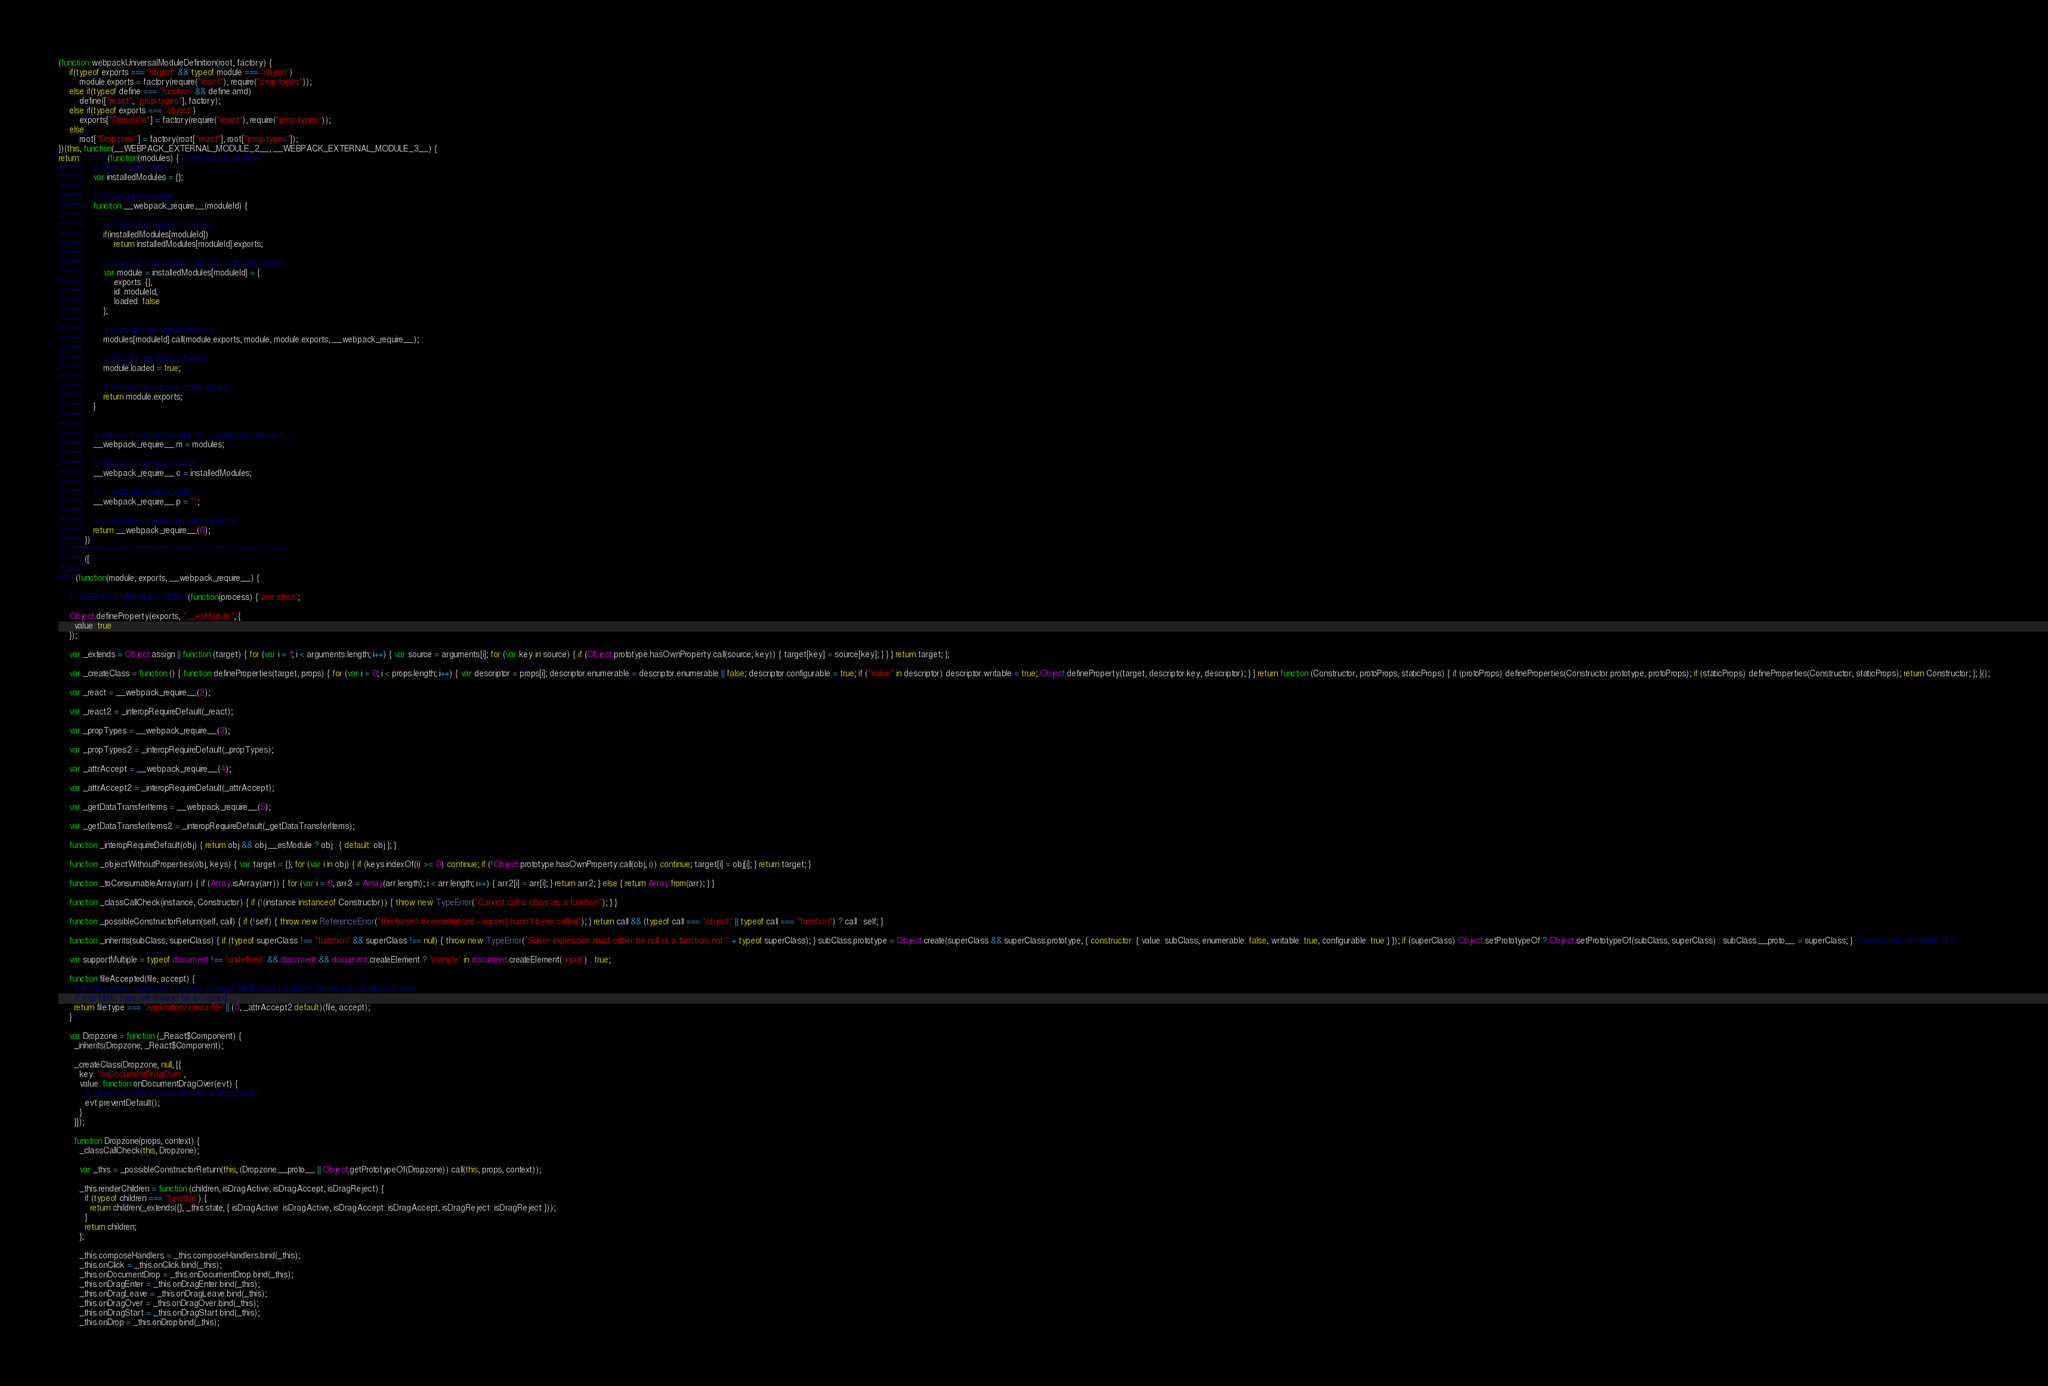Convert code to text. <code><loc_0><loc_0><loc_500><loc_500><_JavaScript_>(function webpackUniversalModuleDefinition(root, factory) {
	if(typeof exports === 'object' && typeof module === 'object')
		module.exports = factory(require("react"), require("prop-types"));
	else if(typeof define === 'function' && define.amd)
		define(["react", "prop-types"], factory);
	else if(typeof exports === 'object')
		exports["Dropzone"] = factory(require("react"), require("prop-types"));
	else
		root["Dropzone"] = factory(root["react"], root["prop-types"]);
})(this, function(__WEBPACK_EXTERNAL_MODULE_2__, __WEBPACK_EXTERNAL_MODULE_3__) {
return /******/ (function(modules) { // webpackBootstrap
/******/ 	// The module cache
/******/ 	var installedModules = {};
/******/
/******/ 	// The require function
/******/ 	function __webpack_require__(moduleId) {
/******/
/******/ 		// Check if module is in cache
/******/ 		if(installedModules[moduleId])
/******/ 			return installedModules[moduleId].exports;
/******/
/******/ 		// Create a new module (and put it into the cache)
/******/ 		var module = installedModules[moduleId] = {
/******/ 			exports: {},
/******/ 			id: moduleId,
/******/ 			loaded: false
/******/ 		};
/******/
/******/ 		// Execute the module function
/******/ 		modules[moduleId].call(module.exports, module, module.exports, __webpack_require__);
/******/
/******/ 		// Flag the module as loaded
/******/ 		module.loaded = true;
/******/
/******/ 		// Return the exports of the module
/******/ 		return module.exports;
/******/ 	}
/******/
/******/
/******/ 	// expose the modules object (__webpack_modules__)
/******/ 	__webpack_require__.m = modules;
/******/
/******/ 	// expose the module cache
/******/ 	__webpack_require__.c = installedModules;
/******/
/******/ 	// __webpack_public_path__
/******/ 	__webpack_require__.p = "";
/******/
/******/ 	// Load entry module and return exports
/******/ 	return __webpack_require__(0);
/******/ })
/************************************************************************/
/******/ ([
/* 0 */
/***/ (function(module, exports, __webpack_require__) {

	/* WEBPACK VAR INJECTION */(function(process) {'use strict';
	
	Object.defineProperty(exports, "__esModule", {
	  value: true
	});
	
	var _extends = Object.assign || function (target) { for (var i = 1; i < arguments.length; i++) { var source = arguments[i]; for (var key in source) { if (Object.prototype.hasOwnProperty.call(source, key)) { target[key] = source[key]; } } } return target; };
	
	var _createClass = function () { function defineProperties(target, props) { for (var i = 0; i < props.length; i++) { var descriptor = props[i]; descriptor.enumerable = descriptor.enumerable || false; descriptor.configurable = true; if ("value" in descriptor) descriptor.writable = true; Object.defineProperty(target, descriptor.key, descriptor); } } return function (Constructor, protoProps, staticProps) { if (protoProps) defineProperties(Constructor.prototype, protoProps); if (staticProps) defineProperties(Constructor, staticProps); return Constructor; }; }();
	
	var _react = __webpack_require__(2);
	
	var _react2 = _interopRequireDefault(_react);
	
	var _propTypes = __webpack_require__(3);
	
	var _propTypes2 = _interopRequireDefault(_propTypes);
	
	var _attrAccept = __webpack_require__(4);
	
	var _attrAccept2 = _interopRequireDefault(_attrAccept);
	
	var _getDataTransferItems = __webpack_require__(5);
	
	var _getDataTransferItems2 = _interopRequireDefault(_getDataTransferItems);
	
	function _interopRequireDefault(obj) { return obj && obj.__esModule ? obj : { default: obj }; }
	
	function _objectWithoutProperties(obj, keys) { var target = {}; for (var i in obj) { if (keys.indexOf(i) >= 0) continue; if (!Object.prototype.hasOwnProperty.call(obj, i)) continue; target[i] = obj[i]; } return target; }
	
	function _toConsumableArray(arr) { if (Array.isArray(arr)) { for (var i = 0, arr2 = Array(arr.length); i < arr.length; i++) { arr2[i] = arr[i]; } return arr2; } else { return Array.from(arr); } }
	
	function _classCallCheck(instance, Constructor) { if (!(instance instanceof Constructor)) { throw new TypeError("Cannot call a class as a function"); } }
	
	function _possibleConstructorReturn(self, call) { if (!self) { throw new ReferenceError("this hasn't been initialised - super() hasn't been called"); } return call && (typeof call === "object" || typeof call === "function") ? call : self; }
	
	function _inherits(subClass, superClass) { if (typeof superClass !== "function" && superClass !== null) { throw new TypeError("Super expression must either be null or a function, not " + typeof superClass); } subClass.prototype = Object.create(superClass && superClass.prototype, { constructor: { value: subClass, enumerable: false, writable: true, configurable: true } }); if (superClass) Object.setPrototypeOf ? Object.setPrototypeOf(subClass, superClass) : subClass.__proto__ = superClass; } /* eslint prefer-template: 0 */
	
	var supportMultiple = typeof document !== 'undefined' && document && document.createElement ? 'multiple' in document.createElement('input') : true;
	
	function fileAccepted(file, accept) {
	  // Firefox versions prior to 53 return a bogus MIME type for every file drag, so dragovers with
	  // that MIME type will always be accepted
	  return file.type === 'application/x-moz-file' || (0, _attrAccept2.default)(file, accept);
	}
	
	var Dropzone = function (_React$Component) {
	  _inherits(Dropzone, _React$Component);
	
	  _createClass(Dropzone, null, [{
	    key: 'onDocumentDragOver',
	    value: function onDocumentDragOver(evt) {
	      // allow the entire document to be a drag target
	      evt.preventDefault();
	    }
	  }]);
	
	  function Dropzone(props, context) {
	    _classCallCheck(this, Dropzone);
	
	    var _this = _possibleConstructorReturn(this, (Dropzone.__proto__ || Object.getPrototypeOf(Dropzone)).call(this, props, context));
	
	    _this.renderChildren = function (children, isDragActive, isDragAccept, isDragReject) {
	      if (typeof children === 'function') {
	        return children(_extends({}, _this.state, { isDragActive: isDragActive, isDragAccept: isDragAccept, isDragReject: isDragReject }));
	      }
	      return children;
	    };
	
	    _this.composeHandlers = _this.composeHandlers.bind(_this);
	    _this.onClick = _this.onClick.bind(_this);
	    _this.onDocumentDrop = _this.onDocumentDrop.bind(_this);
	    _this.onDragEnter = _this.onDragEnter.bind(_this);
	    _this.onDragLeave = _this.onDragLeave.bind(_this);
	    _this.onDragOver = _this.onDragOver.bind(_this);
	    _this.onDragStart = _this.onDragStart.bind(_this);
	    _this.onDrop = _this.onDrop.bind(_this);</code> 